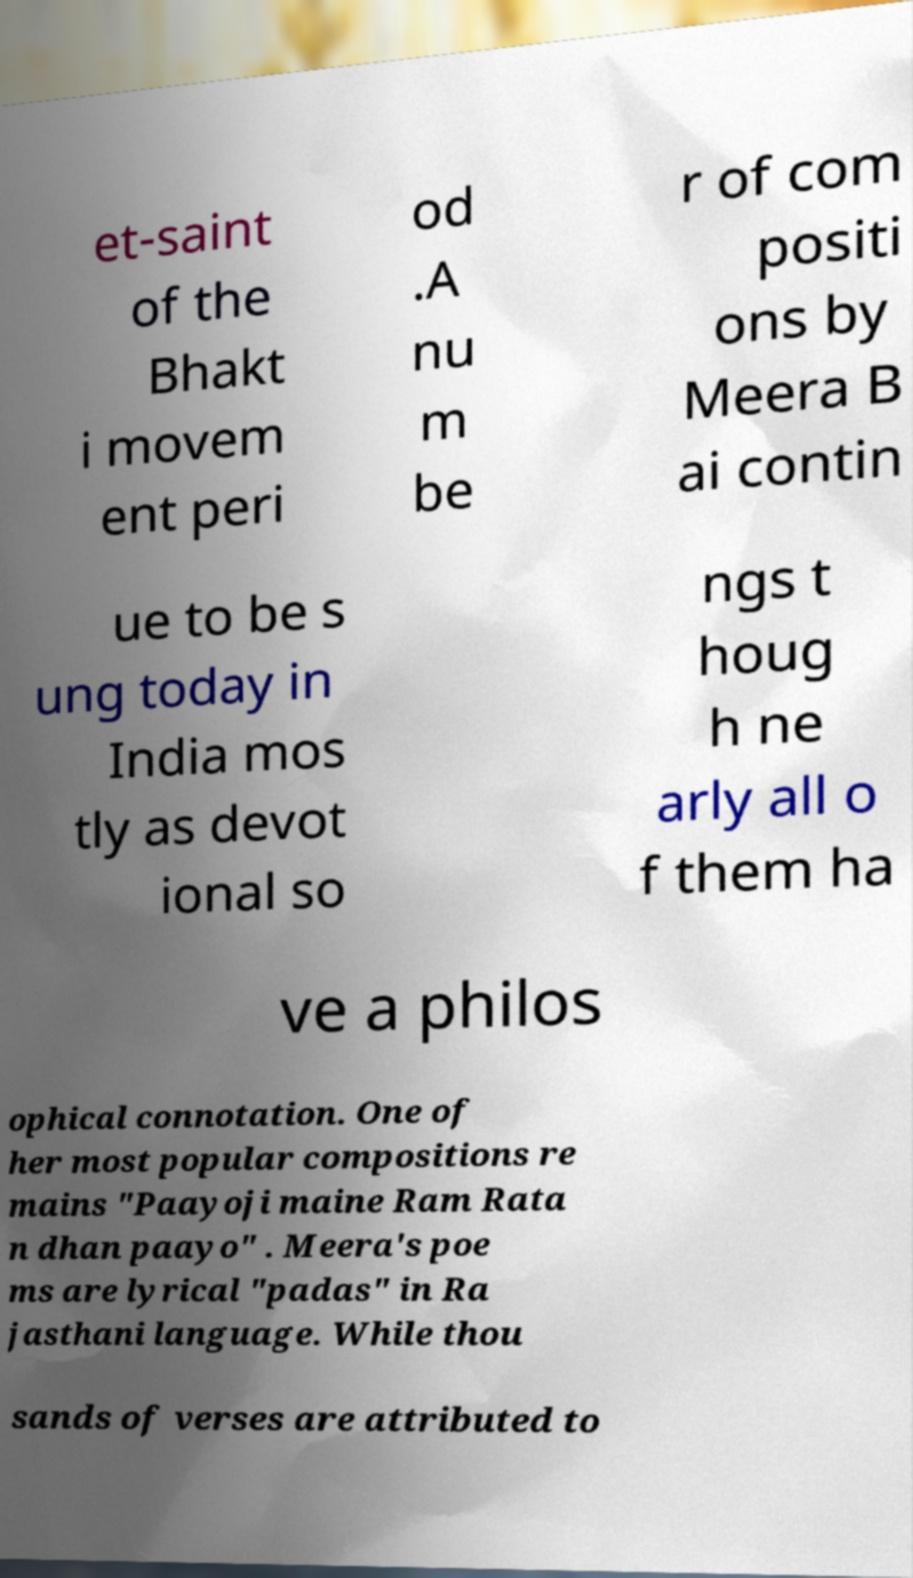Could you assist in decoding the text presented in this image and type it out clearly? et-saint of the Bhakt i movem ent peri od .A nu m be r of com positi ons by Meera B ai contin ue to be s ung today in India mos tly as devot ional so ngs t houg h ne arly all o f them ha ve a philos ophical connotation. One of her most popular compositions re mains "Paayoji maine Ram Rata n dhan paayo" . Meera's poe ms are lyrical "padas" in Ra jasthani language. While thou sands of verses are attributed to 